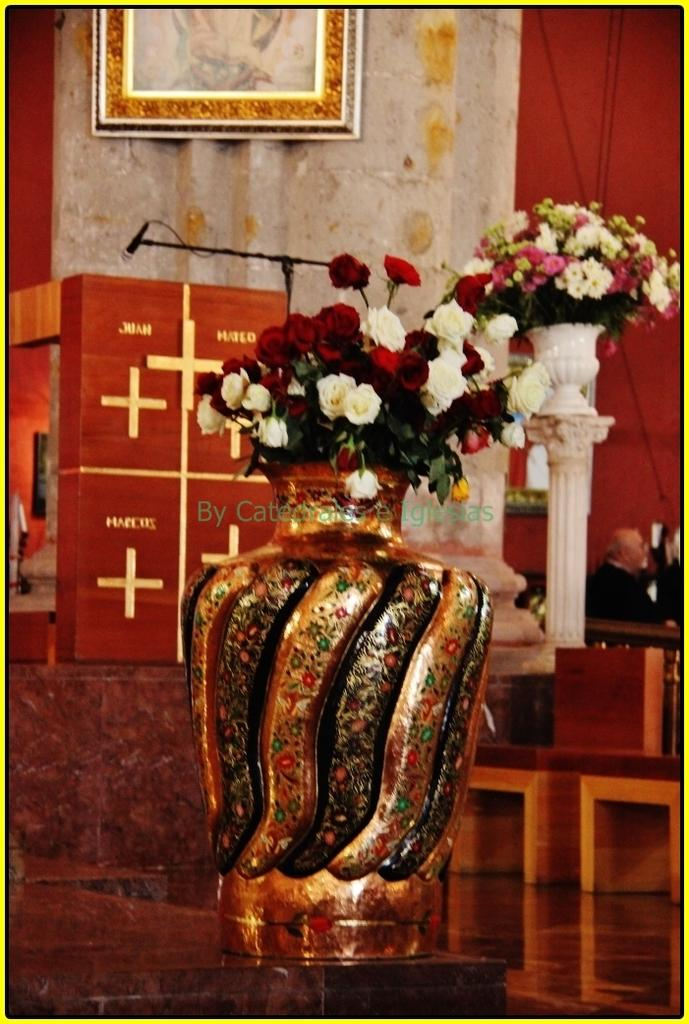What is in the vase that is visible in the image? There are flowers in a vase in the image. Where is the vase located in the image? The vase is placed on the floor. What can be seen in the background of the image? There is a curtain, a photograph, and a wall in the background of the image. What type of cherry is being offered at the store in the image? There is no store or cherry present in the image; it features flowers in a vase on the floor with a curtain, a photograph, and a wall in the background. 